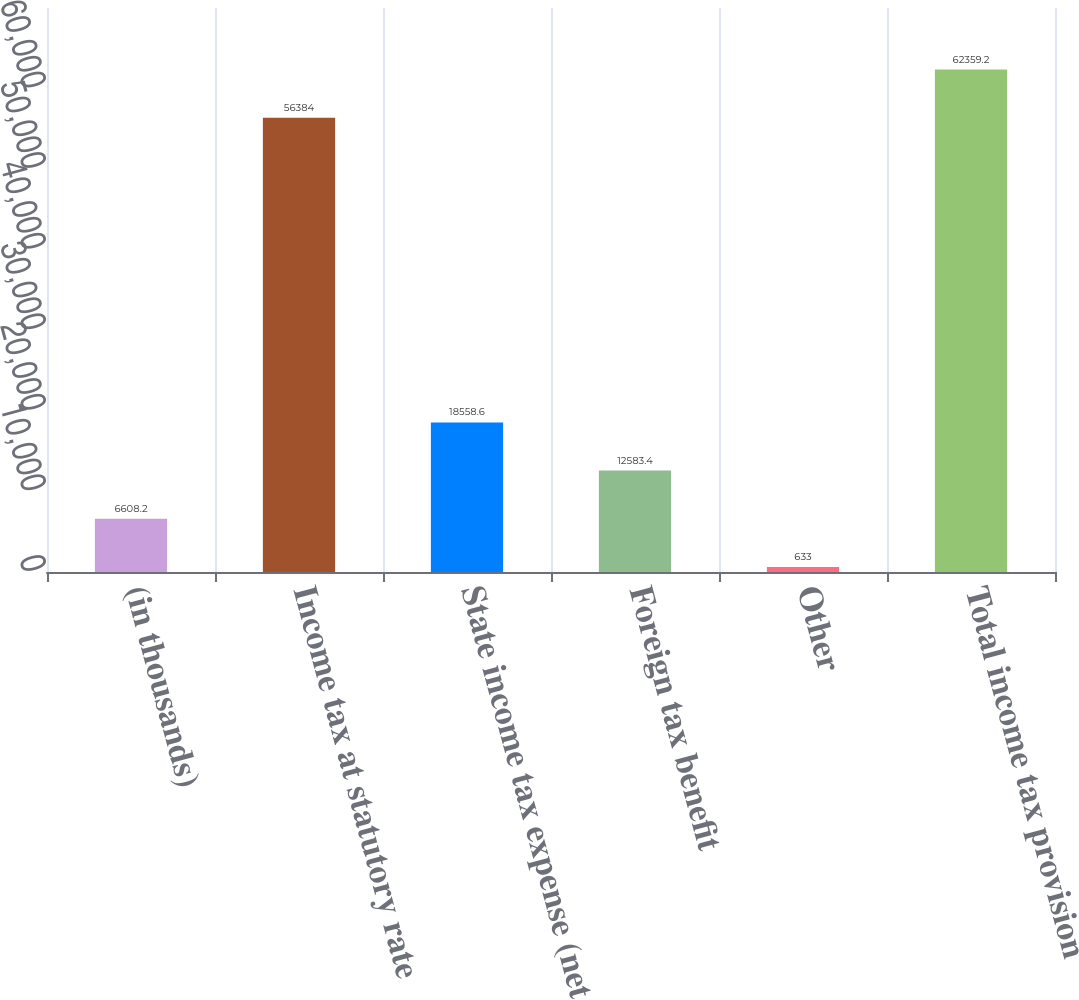Convert chart to OTSL. <chart><loc_0><loc_0><loc_500><loc_500><bar_chart><fcel>(in thousands)<fcel>Income tax at statutory rate<fcel>State income tax expense (net<fcel>Foreign tax benefit<fcel>Other<fcel>Total income tax provision<nl><fcel>6608.2<fcel>56384<fcel>18558.6<fcel>12583.4<fcel>633<fcel>62359.2<nl></chart> 